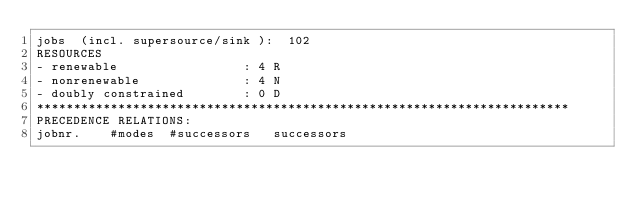<code> <loc_0><loc_0><loc_500><loc_500><_ObjectiveC_>jobs  (incl. supersource/sink ):	102
RESOURCES
- renewable                 : 4 R
- nonrenewable              : 4 N
- doubly constrained        : 0 D
************************************************************************
PRECEDENCE RELATIONS:
jobnr.    #modes  #successors   successors</code> 